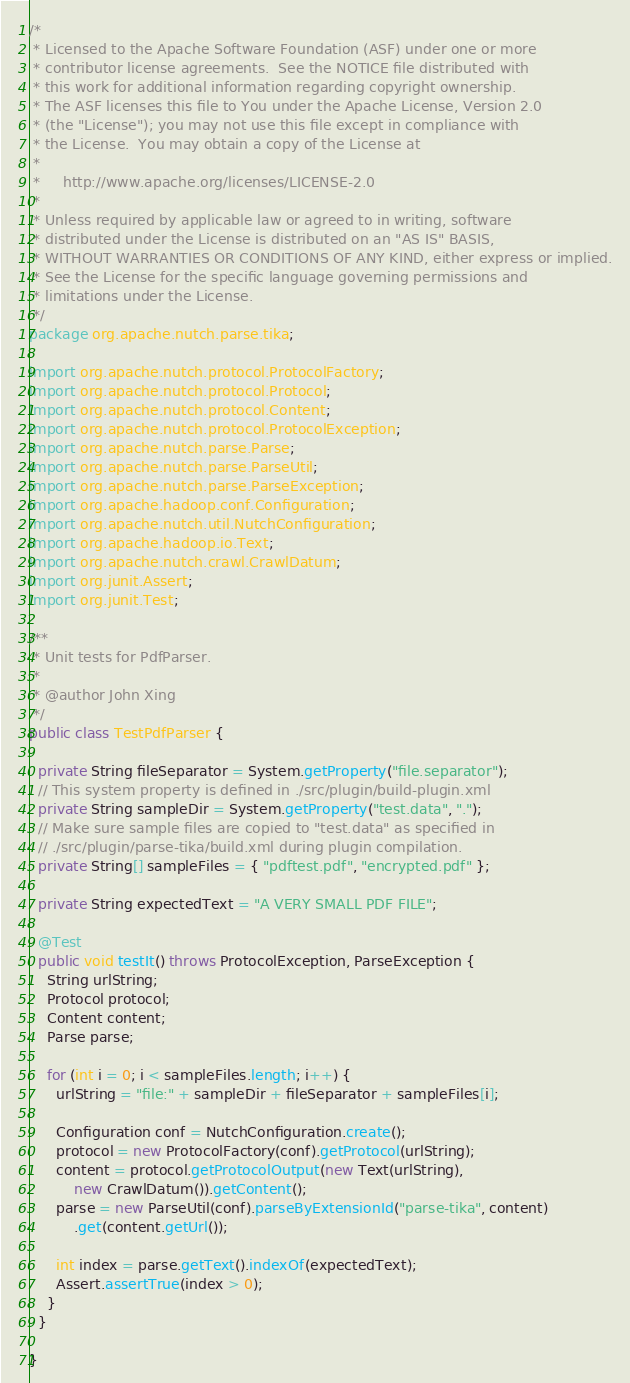Convert code to text. <code><loc_0><loc_0><loc_500><loc_500><_Java_>/*
 * Licensed to the Apache Software Foundation (ASF) under one or more
 * contributor license agreements.  See the NOTICE file distributed with
 * this work for additional information regarding copyright ownership.
 * The ASF licenses this file to You under the Apache License, Version 2.0
 * (the "License"); you may not use this file except in compliance with
 * the License.  You may obtain a copy of the License at
 *
 *     http://www.apache.org/licenses/LICENSE-2.0
 *
 * Unless required by applicable law or agreed to in writing, software
 * distributed under the License is distributed on an "AS IS" BASIS,
 * WITHOUT WARRANTIES OR CONDITIONS OF ANY KIND, either express or implied.
 * See the License for the specific language governing permissions and
 * limitations under the License.
 */
package org.apache.nutch.parse.tika;

import org.apache.nutch.protocol.ProtocolFactory;
import org.apache.nutch.protocol.Protocol;
import org.apache.nutch.protocol.Content;
import org.apache.nutch.protocol.ProtocolException;
import org.apache.nutch.parse.Parse;
import org.apache.nutch.parse.ParseUtil;
import org.apache.nutch.parse.ParseException;
import org.apache.hadoop.conf.Configuration;
import org.apache.nutch.util.NutchConfiguration;
import org.apache.hadoop.io.Text;
import org.apache.nutch.crawl.CrawlDatum;
import org.junit.Assert;
import org.junit.Test;

/**
 * Unit tests for PdfParser.
 * 
 * @author John Xing
 */
public class TestPdfParser {

  private String fileSeparator = System.getProperty("file.separator");
  // This system property is defined in ./src/plugin/build-plugin.xml
  private String sampleDir = System.getProperty("test.data", ".");
  // Make sure sample files are copied to "test.data" as specified in
  // ./src/plugin/parse-tika/build.xml during plugin compilation.
  private String[] sampleFiles = { "pdftest.pdf", "encrypted.pdf" };

  private String expectedText = "A VERY SMALL PDF FILE";

  @Test
  public void testIt() throws ProtocolException, ParseException {
    String urlString;
    Protocol protocol;
    Content content;
    Parse parse;

    for (int i = 0; i < sampleFiles.length; i++) {
      urlString = "file:" + sampleDir + fileSeparator + sampleFiles[i];

      Configuration conf = NutchConfiguration.create();
      protocol = new ProtocolFactory(conf).getProtocol(urlString);
      content = protocol.getProtocolOutput(new Text(urlString),
          new CrawlDatum()).getContent();
      parse = new ParseUtil(conf).parseByExtensionId("parse-tika", content)
          .get(content.getUrl());

      int index = parse.getText().indexOf(expectedText);
      Assert.assertTrue(index > 0);
    }
  }

}
</code> 